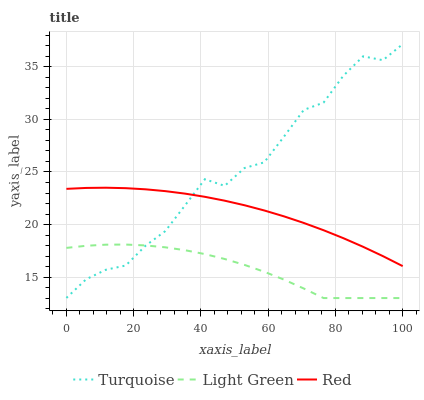Does Light Green have the minimum area under the curve?
Answer yes or no. Yes. Does Turquoise have the maximum area under the curve?
Answer yes or no. Yes. Does Red have the minimum area under the curve?
Answer yes or no. No. Does Red have the maximum area under the curve?
Answer yes or no. No. Is Red the smoothest?
Answer yes or no. Yes. Is Turquoise the roughest?
Answer yes or no. Yes. Is Light Green the smoothest?
Answer yes or no. No. Is Light Green the roughest?
Answer yes or no. No. Does Light Green have the lowest value?
Answer yes or no. Yes. Does Red have the lowest value?
Answer yes or no. No. Does Turquoise have the highest value?
Answer yes or no. Yes. Does Red have the highest value?
Answer yes or no. No. Is Light Green less than Red?
Answer yes or no. Yes. Is Red greater than Light Green?
Answer yes or no. Yes. Does Turquoise intersect Light Green?
Answer yes or no. Yes. Is Turquoise less than Light Green?
Answer yes or no. No. Is Turquoise greater than Light Green?
Answer yes or no. No. Does Light Green intersect Red?
Answer yes or no. No. 